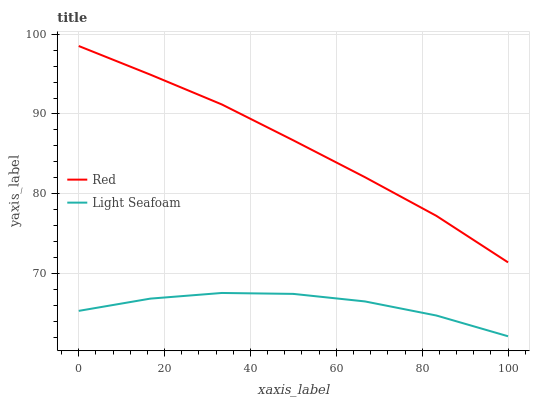Does Light Seafoam have the minimum area under the curve?
Answer yes or no. Yes. Does Red have the maximum area under the curve?
Answer yes or no. Yes. Does Red have the minimum area under the curve?
Answer yes or no. No. Is Red the smoothest?
Answer yes or no. Yes. Is Light Seafoam the roughest?
Answer yes or no. Yes. Is Red the roughest?
Answer yes or no. No. Does Red have the lowest value?
Answer yes or no. No. Is Light Seafoam less than Red?
Answer yes or no. Yes. Is Red greater than Light Seafoam?
Answer yes or no. Yes. Does Light Seafoam intersect Red?
Answer yes or no. No. 